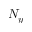<formula> <loc_0><loc_0><loc_500><loc_500>N _ { y }</formula> 